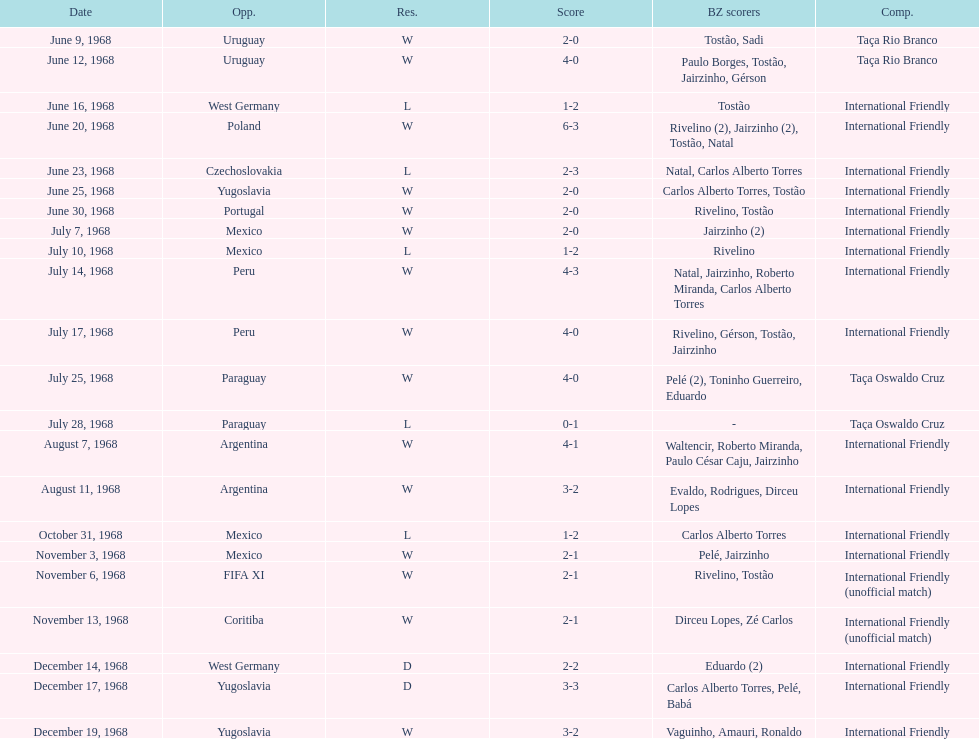Would you mind parsing the complete table? {'header': ['Date', 'Opp.', 'Res.', 'Score', 'BZ scorers', 'Comp.'], 'rows': [['June 9, 1968', 'Uruguay', 'W', '2-0', 'Tostão, Sadi', 'Taça Rio Branco'], ['June 12, 1968', 'Uruguay', 'W', '4-0', 'Paulo Borges, Tostão, Jairzinho, Gérson', 'Taça Rio Branco'], ['June 16, 1968', 'West Germany', 'L', '1-2', 'Tostão', 'International Friendly'], ['June 20, 1968', 'Poland', 'W', '6-3', 'Rivelino (2), Jairzinho (2), Tostão, Natal', 'International Friendly'], ['June 23, 1968', 'Czechoslovakia', 'L', '2-3', 'Natal, Carlos Alberto Torres', 'International Friendly'], ['June 25, 1968', 'Yugoslavia', 'W', '2-0', 'Carlos Alberto Torres, Tostão', 'International Friendly'], ['June 30, 1968', 'Portugal', 'W', '2-0', 'Rivelino, Tostão', 'International Friendly'], ['July 7, 1968', 'Mexico', 'W', '2-0', 'Jairzinho (2)', 'International Friendly'], ['July 10, 1968', 'Mexico', 'L', '1-2', 'Rivelino', 'International Friendly'], ['July 14, 1968', 'Peru', 'W', '4-3', 'Natal, Jairzinho, Roberto Miranda, Carlos Alberto Torres', 'International Friendly'], ['July 17, 1968', 'Peru', 'W', '4-0', 'Rivelino, Gérson, Tostão, Jairzinho', 'International Friendly'], ['July 25, 1968', 'Paraguay', 'W', '4-0', 'Pelé (2), Toninho Guerreiro, Eduardo', 'Taça Oswaldo Cruz'], ['July 28, 1968', 'Paraguay', 'L', '0-1', '-', 'Taça Oswaldo Cruz'], ['August 7, 1968', 'Argentina', 'W', '4-1', 'Waltencir, Roberto Miranda, Paulo César Caju, Jairzinho', 'International Friendly'], ['August 11, 1968', 'Argentina', 'W', '3-2', 'Evaldo, Rodrigues, Dirceu Lopes', 'International Friendly'], ['October 31, 1968', 'Mexico', 'L', '1-2', 'Carlos Alberto Torres', 'International Friendly'], ['November 3, 1968', 'Mexico', 'W', '2-1', 'Pelé, Jairzinho', 'International Friendly'], ['November 6, 1968', 'FIFA XI', 'W', '2-1', 'Rivelino, Tostão', 'International Friendly (unofficial match)'], ['November 13, 1968', 'Coritiba', 'W', '2-1', 'Dirceu Lopes, Zé Carlos', 'International Friendly (unofficial match)'], ['December 14, 1968', 'West Germany', 'D', '2-2', 'Eduardo (2)', 'International Friendly'], ['December 17, 1968', 'Yugoslavia', 'D', '3-3', 'Carlos Alberto Torres, Pelé, Babá', 'International Friendly'], ['December 19, 1968', 'Yugoslavia', 'W', '3-2', 'Vaguinho, Amauri, Ronaldo', 'International Friendly']]} Who played brazil previous to the game on june 30th? Yugoslavia. 